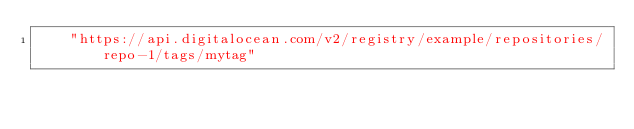Convert code to text. <code><loc_0><loc_0><loc_500><loc_500><_YAML_>    "https://api.digitalocean.com/v2/registry/example/repositories/repo-1/tags/mytag"
</code> 